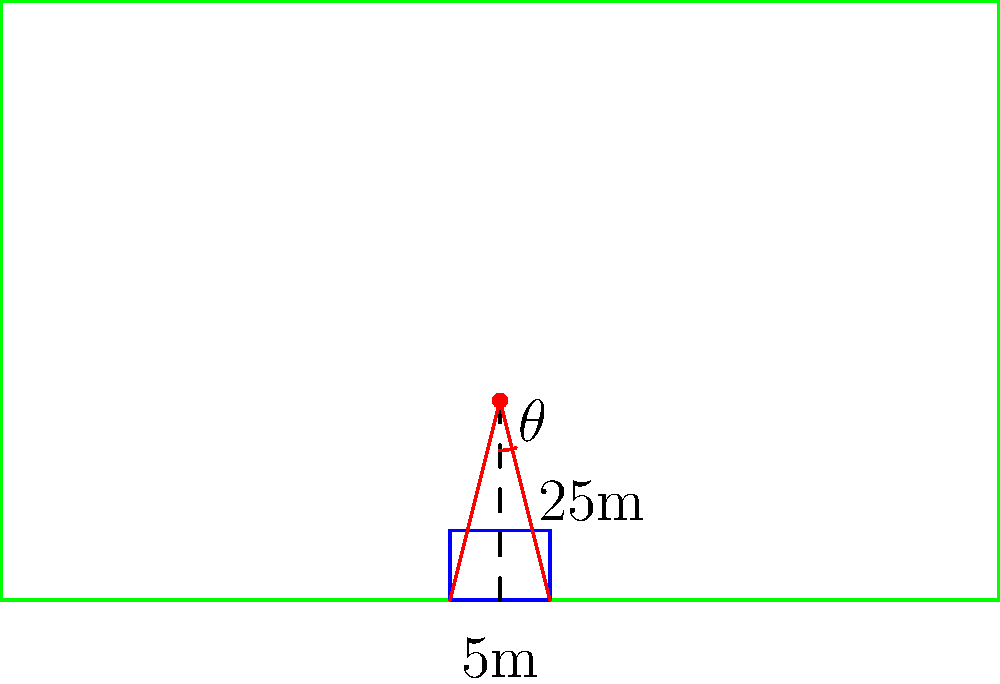As a skilled midfielder, you're preparing for a free kick 25 meters away from the center of the goal. The goal is 10 meters wide. Calculate the optimal angle $\theta$ (in degrees) for the kick to maximize your chances of scoring, assuming you aim for either goal post. Use the diagram provided and round your answer to two decimal places. To find the optimal angle for the free kick, we'll follow these steps:

1) First, we need to identify the right triangle formed by the ball position and either goal post.

2) We know:
   - The distance to the goal line is 25 meters
   - Half the goal width is 5 meters (10/2)

3) We can use the tangent function to find the angle:

   $$\tan(\theta) = \frac{\text{opposite}}{\text{adjacent}} = \frac{5}{25} = 0.2$$

4) To find $\theta$, we use the inverse tangent (arctangent) function:

   $$\theta = \arctan(0.2)$$

5) Convert this to degrees:

   $$\theta = \arctan(0.2) \cdot \frac{180}{\pi} \approx 11.3099325$$

6) Rounding to two decimal places:

   $$\theta \approx 11.31^\circ$$

This angle represents the optimal angle from the center line to either goal post. The total angle between the two goal posts from the ball's position would be double this value.
Answer: $11.31^\circ$ 